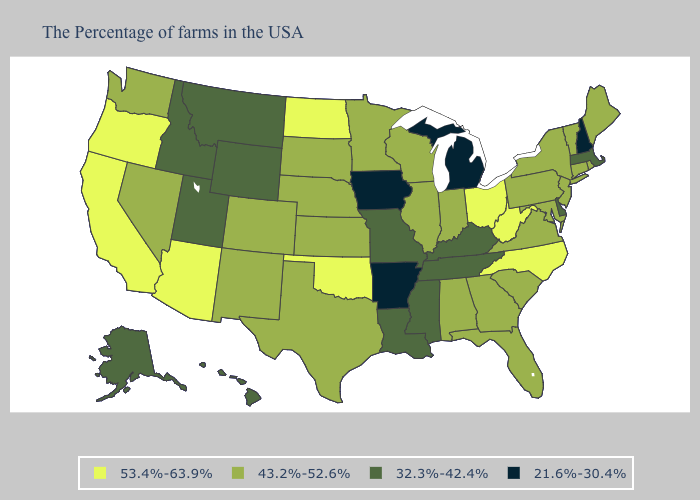Name the states that have a value in the range 43.2%-52.6%?
Give a very brief answer. Maine, Rhode Island, Vermont, Connecticut, New York, New Jersey, Maryland, Pennsylvania, Virginia, South Carolina, Florida, Georgia, Indiana, Alabama, Wisconsin, Illinois, Minnesota, Kansas, Nebraska, Texas, South Dakota, Colorado, New Mexico, Nevada, Washington. Which states have the lowest value in the MidWest?
Quick response, please. Michigan, Iowa. What is the highest value in states that border Rhode Island?
Write a very short answer. 43.2%-52.6%. What is the highest value in the MidWest ?
Give a very brief answer. 53.4%-63.9%. Does Pennsylvania have the lowest value in the Northeast?
Short answer required. No. What is the value of Arkansas?
Write a very short answer. 21.6%-30.4%. Among the states that border South Dakota , does North Dakota have the highest value?
Quick response, please. Yes. Among the states that border Minnesota , which have the lowest value?
Short answer required. Iowa. Which states have the highest value in the USA?
Concise answer only. North Carolina, West Virginia, Ohio, Oklahoma, North Dakota, Arizona, California, Oregon. Name the states that have a value in the range 43.2%-52.6%?
Give a very brief answer. Maine, Rhode Island, Vermont, Connecticut, New York, New Jersey, Maryland, Pennsylvania, Virginia, South Carolina, Florida, Georgia, Indiana, Alabama, Wisconsin, Illinois, Minnesota, Kansas, Nebraska, Texas, South Dakota, Colorado, New Mexico, Nevada, Washington. How many symbols are there in the legend?
Concise answer only. 4. What is the highest value in the USA?
Short answer required. 53.4%-63.9%. What is the highest value in states that border Maryland?
Keep it brief. 53.4%-63.9%. Name the states that have a value in the range 32.3%-42.4%?
Keep it brief. Massachusetts, Delaware, Kentucky, Tennessee, Mississippi, Louisiana, Missouri, Wyoming, Utah, Montana, Idaho, Alaska, Hawaii. Which states have the lowest value in the USA?
Keep it brief. New Hampshire, Michigan, Arkansas, Iowa. 